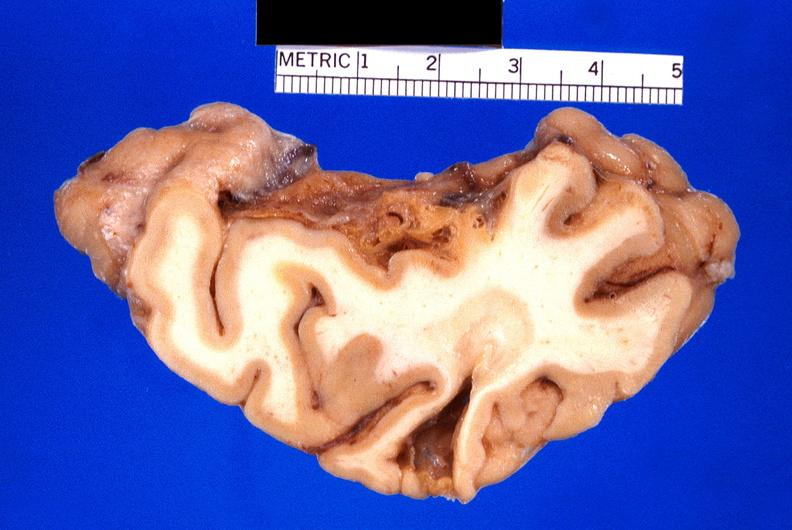s nervous present?
Answer the question using a single word or phrase. Yes 